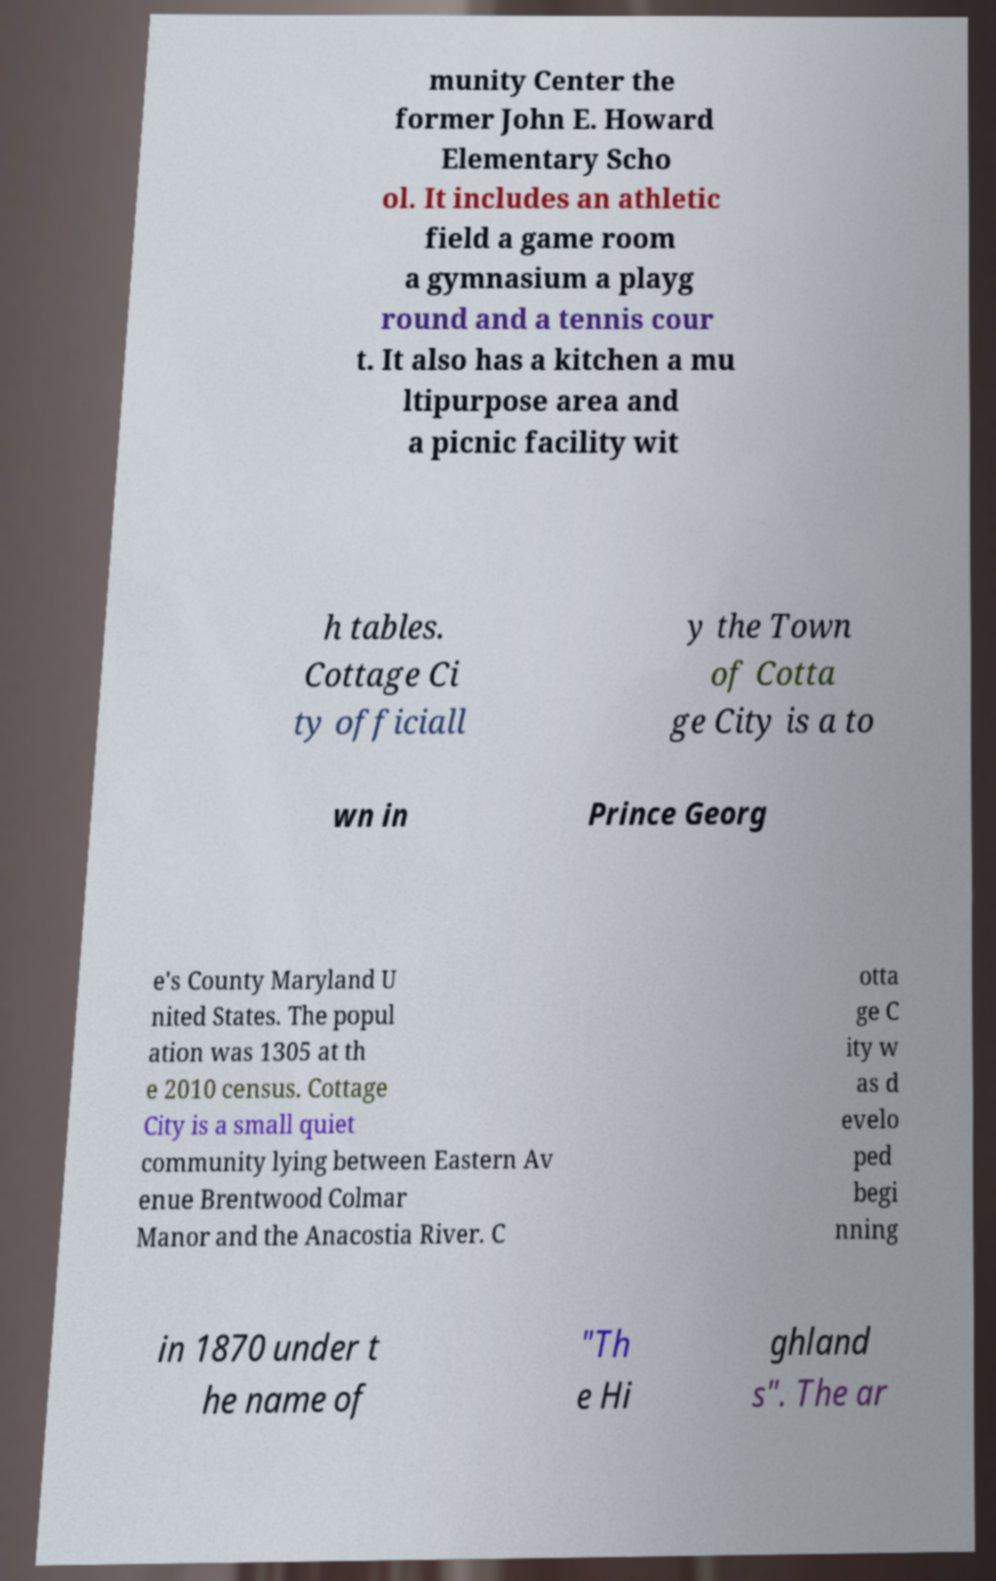Can you read and provide the text displayed in the image?This photo seems to have some interesting text. Can you extract and type it out for me? munity Center the former John E. Howard Elementary Scho ol. It includes an athletic field a game room a gymnasium a playg round and a tennis cour t. It also has a kitchen a mu ltipurpose area and a picnic facility wit h tables. Cottage Ci ty officiall y the Town of Cotta ge City is a to wn in Prince Georg e's County Maryland U nited States. The popul ation was 1305 at th e 2010 census. Cottage City is a small quiet community lying between Eastern Av enue Brentwood Colmar Manor and the Anacostia River. C otta ge C ity w as d evelo ped begi nning in 1870 under t he name of "Th e Hi ghland s". The ar 